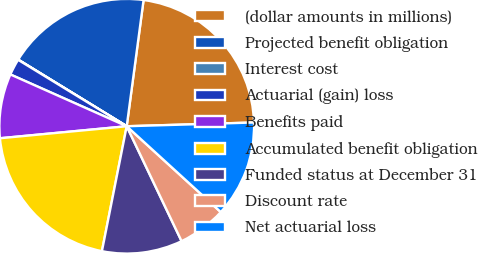<chart> <loc_0><loc_0><loc_500><loc_500><pie_chart><fcel>(dollar amounts in millions)<fcel>Projected benefit obligation<fcel>Interest cost<fcel>Actuarial (gain) loss<fcel>Benefits paid<fcel>Accumulated benefit obligation<fcel>Funded status at December 31<fcel>Discount rate<fcel>Net actuarial loss<nl><fcel>22.42%<fcel>18.35%<fcel>0.03%<fcel>2.07%<fcel>8.17%<fcel>20.38%<fcel>10.21%<fcel>6.14%<fcel>12.24%<nl></chart> 